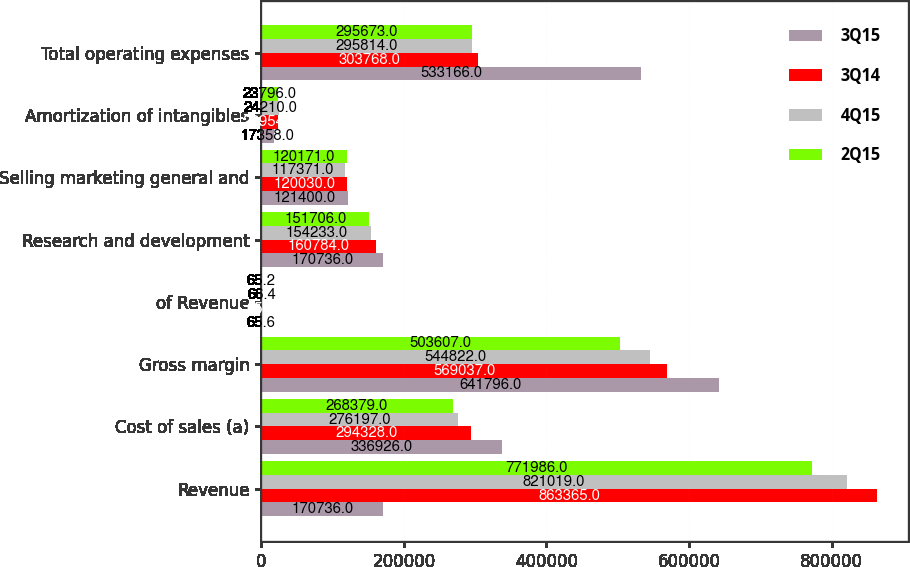Convert chart to OTSL. <chart><loc_0><loc_0><loc_500><loc_500><stacked_bar_chart><ecel><fcel>Revenue<fcel>Cost of sales (a)<fcel>Gross margin<fcel>of Revenue<fcel>Research and development<fcel>Selling marketing general and<fcel>Amortization of intangibles<fcel>Total operating expenses<nl><fcel>3Q15<fcel>170736<fcel>336926<fcel>641796<fcel>65.6<fcel>170736<fcel>121400<fcel>17358<fcel>533166<nl><fcel>3Q14<fcel>863365<fcel>294328<fcel>569037<fcel>65.9<fcel>160784<fcel>120030<fcel>22954<fcel>303768<nl><fcel>4Q15<fcel>821019<fcel>276197<fcel>544822<fcel>66.4<fcel>154233<fcel>117371<fcel>24210<fcel>295814<nl><fcel>2Q15<fcel>771986<fcel>268379<fcel>503607<fcel>65.2<fcel>151706<fcel>120171<fcel>23796<fcel>295673<nl></chart> 